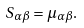Convert formula to latex. <formula><loc_0><loc_0><loc_500><loc_500>S _ { \alpha \beta } = \mu _ { \alpha \beta } .</formula> 